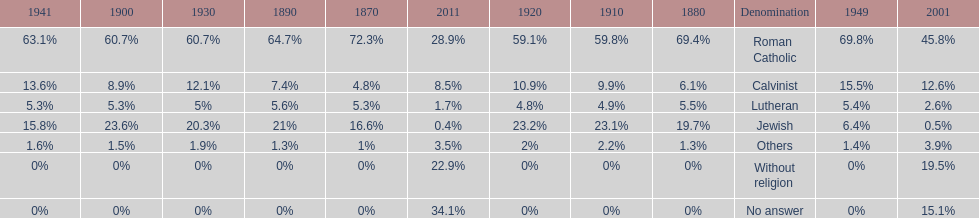The percentage of people who identified as calvinist was, at most, how much? 15.5%. 